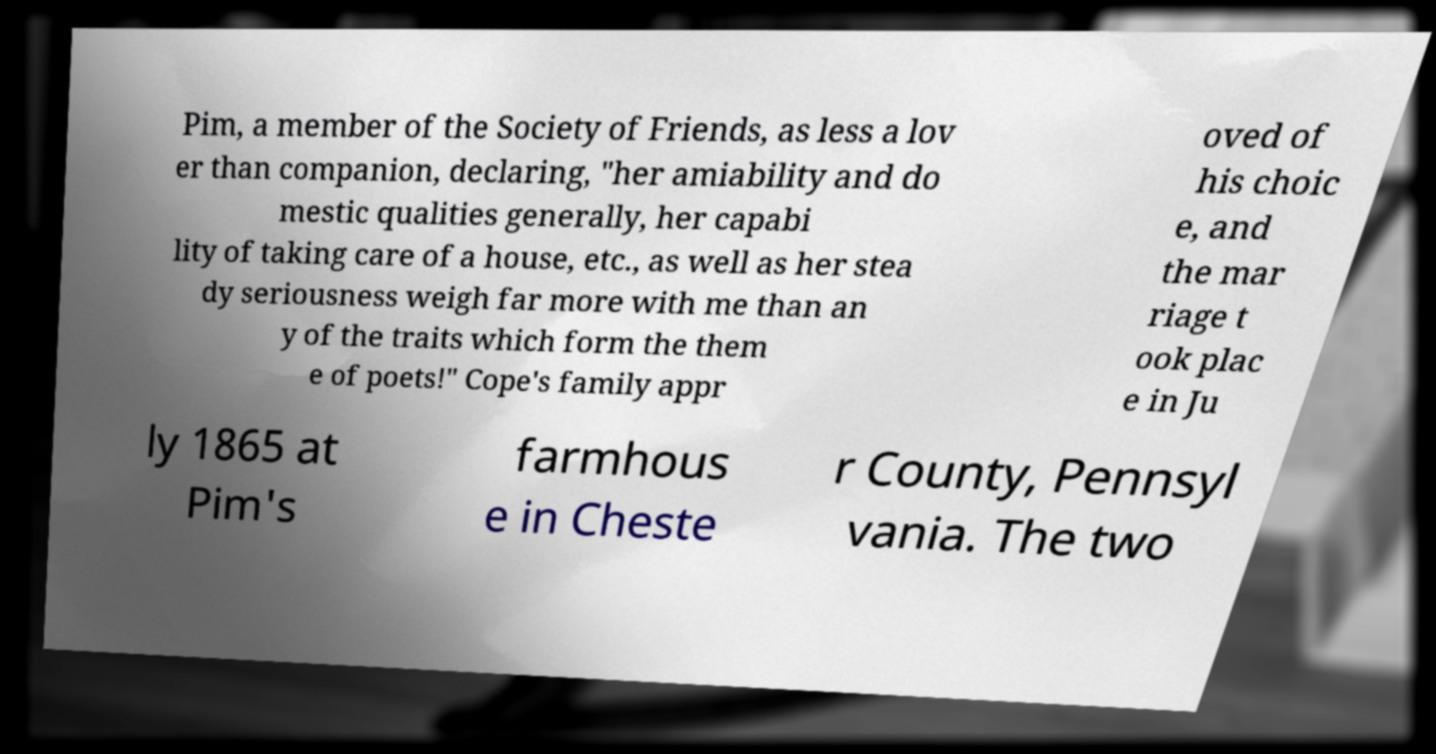Please read and relay the text visible in this image. What does it say? Pim, a member of the Society of Friends, as less a lov er than companion, declaring, "her amiability and do mestic qualities generally, her capabi lity of taking care of a house, etc., as well as her stea dy seriousness weigh far more with me than an y of the traits which form the them e of poets!" Cope's family appr oved of his choic e, and the mar riage t ook plac e in Ju ly 1865 at Pim's farmhous e in Cheste r County, Pennsyl vania. The two 